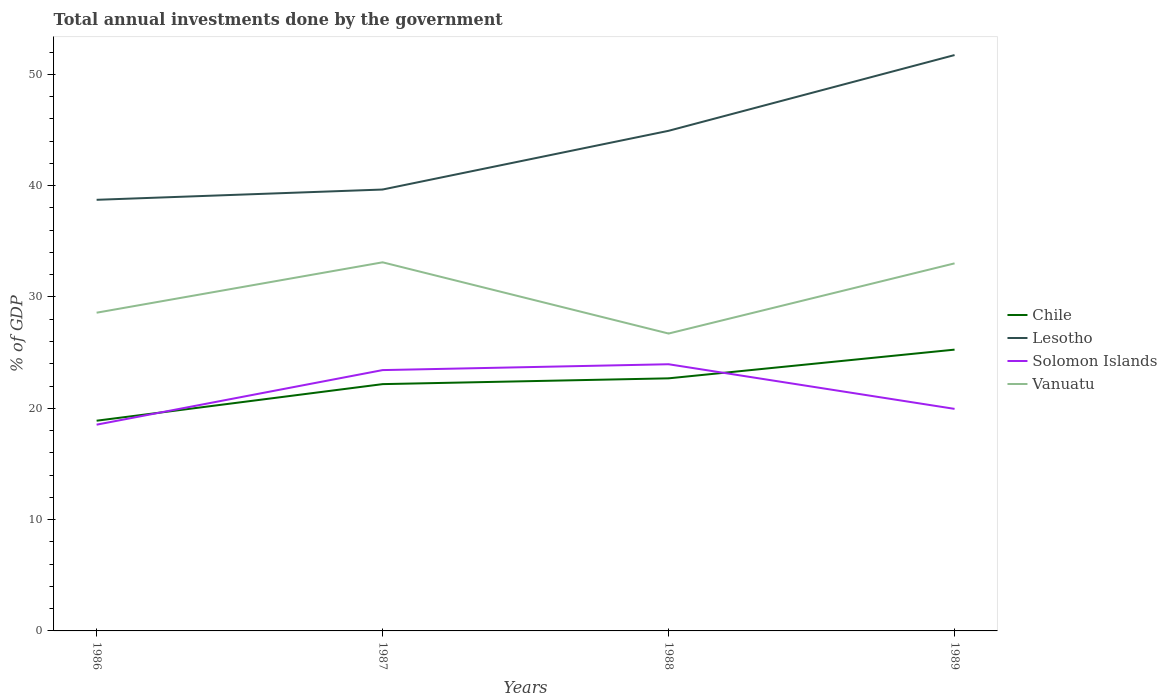Does the line corresponding to Lesotho intersect with the line corresponding to Solomon Islands?
Your response must be concise. No. Across all years, what is the maximum total annual investments done by the government in Chile?
Provide a succinct answer. 18.88. What is the total total annual investments done by the government in Vanuatu in the graph?
Your answer should be very brief. 6.4. What is the difference between the highest and the second highest total annual investments done by the government in Lesotho?
Your answer should be compact. 13. Is the total annual investments done by the government in Solomon Islands strictly greater than the total annual investments done by the government in Chile over the years?
Offer a terse response. No. How many years are there in the graph?
Your answer should be compact. 4. Does the graph contain any zero values?
Make the answer very short. No. How many legend labels are there?
Your answer should be very brief. 4. How are the legend labels stacked?
Your answer should be very brief. Vertical. What is the title of the graph?
Your answer should be compact. Total annual investments done by the government. What is the label or title of the Y-axis?
Offer a very short reply. % of GDP. What is the % of GDP of Chile in 1986?
Provide a succinct answer. 18.88. What is the % of GDP in Lesotho in 1986?
Your answer should be compact. 38.73. What is the % of GDP in Solomon Islands in 1986?
Your answer should be compact. 18.53. What is the % of GDP in Vanuatu in 1986?
Offer a very short reply. 28.59. What is the % of GDP of Chile in 1987?
Your answer should be compact. 22.17. What is the % of GDP of Lesotho in 1987?
Offer a very short reply. 39.65. What is the % of GDP in Solomon Islands in 1987?
Provide a short and direct response. 23.43. What is the % of GDP in Vanuatu in 1987?
Your response must be concise. 33.11. What is the % of GDP of Chile in 1988?
Provide a succinct answer. 22.69. What is the % of GDP in Lesotho in 1988?
Make the answer very short. 44.93. What is the % of GDP of Solomon Islands in 1988?
Your answer should be very brief. 23.96. What is the % of GDP in Vanuatu in 1988?
Make the answer very short. 26.71. What is the % of GDP of Chile in 1989?
Offer a very short reply. 25.27. What is the % of GDP of Lesotho in 1989?
Provide a short and direct response. 51.73. What is the % of GDP in Solomon Islands in 1989?
Ensure brevity in your answer.  19.95. What is the % of GDP of Vanuatu in 1989?
Offer a very short reply. 33.02. Across all years, what is the maximum % of GDP in Chile?
Keep it short and to the point. 25.27. Across all years, what is the maximum % of GDP of Lesotho?
Provide a succinct answer. 51.73. Across all years, what is the maximum % of GDP of Solomon Islands?
Ensure brevity in your answer.  23.96. Across all years, what is the maximum % of GDP of Vanuatu?
Ensure brevity in your answer.  33.11. Across all years, what is the minimum % of GDP of Chile?
Provide a succinct answer. 18.88. Across all years, what is the minimum % of GDP of Lesotho?
Make the answer very short. 38.73. Across all years, what is the minimum % of GDP in Solomon Islands?
Make the answer very short. 18.53. Across all years, what is the minimum % of GDP of Vanuatu?
Offer a terse response. 26.71. What is the total % of GDP of Chile in the graph?
Offer a terse response. 89.01. What is the total % of GDP in Lesotho in the graph?
Your response must be concise. 175.04. What is the total % of GDP of Solomon Islands in the graph?
Give a very brief answer. 85.86. What is the total % of GDP of Vanuatu in the graph?
Provide a succinct answer. 121.43. What is the difference between the % of GDP of Chile in 1986 and that in 1987?
Make the answer very short. -3.29. What is the difference between the % of GDP in Lesotho in 1986 and that in 1987?
Your response must be concise. -0.92. What is the difference between the % of GDP in Solomon Islands in 1986 and that in 1987?
Give a very brief answer. -4.9. What is the difference between the % of GDP of Vanuatu in 1986 and that in 1987?
Offer a terse response. -4.53. What is the difference between the % of GDP in Chile in 1986 and that in 1988?
Provide a succinct answer. -3.81. What is the difference between the % of GDP of Lesotho in 1986 and that in 1988?
Offer a very short reply. -6.2. What is the difference between the % of GDP of Solomon Islands in 1986 and that in 1988?
Your answer should be compact. -5.43. What is the difference between the % of GDP in Vanuatu in 1986 and that in 1988?
Your answer should be compact. 1.87. What is the difference between the % of GDP of Chile in 1986 and that in 1989?
Keep it short and to the point. -6.38. What is the difference between the % of GDP in Lesotho in 1986 and that in 1989?
Give a very brief answer. -13. What is the difference between the % of GDP in Solomon Islands in 1986 and that in 1989?
Provide a succinct answer. -1.42. What is the difference between the % of GDP in Vanuatu in 1986 and that in 1989?
Keep it short and to the point. -4.43. What is the difference between the % of GDP in Chile in 1987 and that in 1988?
Keep it short and to the point. -0.52. What is the difference between the % of GDP of Lesotho in 1987 and that in 1988?
Make the answer very short. -5.28. What is the difference between the % of GDP of Solomon Islands in 1987 and that in 1988?
Keep it short and to the point. -0.53. What is the difference between the % of GDP in Vanuatu in 1987 and that in 1988?
Your response must be concise. 6.4. What is the difference between the % of GDP of Chile in 1987 and that in 1989?
Your answer should be compact. -3.1. What is the difference between the % of GDP in Lesotho in 1987 and that in 1989?
Your response must be concise. -12.08. What is the difference between the % of GDP in Solomon Islands in 1987 and that in 1989?
Your answer should be compact. 3.48. What is the difference between the % of GDP of Vanuatu in 1987 and that in 1989?
Your answer should be very brief. 0.09. What is the difference between the % of GDP in Chile in 1988 and that in 1989?
Make the answer very short. -2.58. What is the difference between the % of GDP in Lesotho in 1988 and that in 1989?
Offer a very short reply. -6.8. What is the difference between the % of GDP of Solomon Islands in 1988 and that in 1989?
Your answer should be very brief. 4.01. What is the difference between the % of GDP in Vanuatu in 1988 and that in 1989?
Your answer should be compact. -6.3. What is the difference between the % of GDP in Chile in 1986 and the % of GDP in Lesotho in 1987?
Make the answer very short. -20.77. What is the difference between the % of GDP in Chile in 1986 and the % of GDP in Solomon Islands in 1987?
Your answer should be very brief. -4.55. What is the difference between the % of GDP of Chile in 1986 and the % of GDP of Vanuatu in 1987?
Make the answer very short. -14.23. What is the difference between the % of GDP in Lesotho in 1986 and the % of GDP in Solomon Islands in 1987?
Provide a short and direct response. 15.3. What is the difference between the % of GDP of Lesotho in 1986 and the % of GDP of Vanuatu in 1987?
Provide a succinct answer. 5.62. What is the difference between the % of GDP of Solomon Islands in 1986 and the % of GDP of Vanuatu in 1987?
Your answer should be very brief. -14.58. What is the difference between the % of GDP in Chile in 1986 and the % of GDP in Lesotho in 1988?
Offer a terse response. -26.04. What is the difference between the % of GDP in Chile in 1986 and the % of GDP in Solomon Islands in 1988?
Give a very brief answer. -5.07. What is the difference between the % of GDP in Chile in 1986 and the % of GDP in Vanuatu in 1988?
Ensure brevity in your answer.  -7.83. What is the difference between the % of GDP in Lesotho in 1986 and the % of GDP in Solomon Islands in 1988?
Provide a succinct answer. 14.77. What is the difference between the % of GDP of Lesotho in 1986 and the % of GDP of Vanuatu in 1988?
Keep it short and to the point. 12.01. What is the difference between the % of GDP of Solomon Islands in 1986 and the % of GDP of Vanuatu in 1988?
Your response must be concise. -8.19. What is the difference between the % of GDP of Chile in 1986 and the % of GDP of Lesotho in 1989?
Offer a terse response. -32.85. What is the difference between the % of GDP in Chile in 1986 and the % of GDP in Solomon Islands in 1989?
Keep it short and to the point. -1.06. What is the difference between the % of GDP in Chile in 1986 and the % of GDP in Vanuatu in 1989?
Provide a succinct answer. -14.13. What is the difference between the % of GDP in Lesotho in 1986 and the % of GDP in Solomon Islands in 1989?
Make the answer very short. 18.78. What is the difference between the % of GDP in Lesotho in 1986 and the % of GDP in Vanuatu in 1989?
Keep it short and to the point. 5.71. What is the difference between the % of GDP in Solomon Islands in 1986 and the % of GDP in Vanuatu in 1989?
Your answer should be compact. -14.49. What is the difference between the % of GDP of Chile in 1987 and the % of GDP of Lesotho in 1988?
Make the answer very short. -22.76. What is the difference between the % of GDP in Chile in 1987 and the % of GDP in Solomon Islands in 1988?
Give a very brief answer. -1.79. What is the difference between the % of GDP in Chile in 1987 and the % of GDP in Vanuatu in 1988?
Make the answer very short. -4.54. What is the difference between the % of GDP of Lesotho in 1987 and the % of GDP of Solomon Islands in 1988?
Provide a short and direct response. 15.7. What is the difference between the % of GDP of Lesotho in 1987 and the % of GDP of Vanuatu in 1988?
Provide a succinct answer. 12.94. What is the difference between the % of GDP of Solomon Islands in 1987 and the % of GDP of Vanuatu in 1988?
Provide a succinct answer. -3.28. What is the difference between the % of GDP in Chile in 1987 and the % of GDP in Lesotho in 1989?
Make the answer very short. -29.56. What is the difference between the % of GDP of Chile in 1987 and the % of GDP of Solomon Islands in 1989?
Ensure brevity in your answer.  2.22. What is the difference between the % of GDP of Chile in 1987 and the % of GDP of Vanuatu in 1989?
Your answer should be very brief. -10.85. What is the difference between the % of GDP in Lesotho in 1987 and the % of GDP in Solomon Islands in 1989?
Offer a very short reply. 19.7. What is the difference between the % of GDP of Lesotho in 1987 and the % of GDP of Vanuatu in 1989?
Offer a terse response. 6.63. What is the difference between the % of GDP of Solomon Islands in 1987 and the % of GDP of Vanuatu in 1989?
Your answer should be very brief. -9.59. What is the difference between the % of GDP in Chile in 1988 and the % of GDP in Lesotho in 1989?
Your answer should be compact. -29.04. What is the difference between the % of GDP of Chile in 1988 and the % of GDP of Solomon Islands in 1989?
Make the answer very short. 2.74. What is the difference between the % of GDP of Chile in 1988 and the % of GDP of Vanuatu in 1989?
Your answer should be compact. -10.33. What is the difference between the % of GDP of Lesotho in 1988 and the % of GDP of Solomon Islands in 1989?
Make the answer very short. 24.98. What is the difference between the % of GDP of Lesotho in 1988 and the % of GDP of Vanuatu in 1989?
Offer a terse response. 11.91. What is the difference between the % of GDP of Solomon Islands in 1988 and the % of GDP of Vanuatu in 1989?
Offer a terse response. -9.06. What is the average % of GDP of Chile per year?
Make the answer very short. 22.25. What is the average % of GDP in Lesotho per year?
Make the answer very short. 43.76. What is the average % of GDP in Solomon Islands per year?
Give a very brief answer. 21.47. What is the average % of GDP in Vanuatu per year?
Offer a terse response. 30.36. In the year 1986, what is the difference between the % of GDP of Chile and % of GDP of Lesotho?
Make the answer very short. -19.84. In the year 1986, what is the difference between the % of GDP in Chile and % of GDP in Solomon Islands?
Give a very brief answer. 0.36. In the year 1986, what is the difference between the % of GDP in Chile and % of GDP in Vanuatu?
Your answer should be very brief. -9.7. In the year 1986, what is the difference between the % of GDP of Lesotho and % of GDP of Solomon Islands?
Provide a succinct answer. 20.2. In the year 1986, what is the difference between the % of GDP of Lesotho and % of GDP of Vanuatu?
Keep it short and to the point. 10.14. In the year 1986, what is the difference between the % of GDP of Solomon Islands and % of GDP of Vanuatu?
Provide a succinct answer. -10.06. In the year 1987, what is the difference between the % of GDP of Chile and % of GDP of Lesotho?
Provide a succinct answer. -17.48. In the year 1987, what is the difference between the % of GDP of Chile and % of GDP of Solomon Islands?
Offer a terse response. -1.26. In the year 1987, what is the difference between the % of GDP of Chile and % of GDP of Vanuatu?
Keep it short and to the point. -10.94. In the year 1987, what is the difference between the % of GDP in Lesotho and % of GDP in Solomon Islands?
Your response must be concise. 16.22. In the year 1987, what is the difference between the % of GDP of Lesotho and % of GDP of Vanuatu?
Keep it short and to the point. 6.54. In the year 1987, what is the difference between the % of GDP of Solomon Islands and % of GDP of Vanuatu?
Your response must be concise. -9.68. In the year 1988, what is the difference between the % of GDP in Chile and % of GDP in Lesotho?
Give a very brief answer. -22.24. In the year 1988, what is the difference between the % of GDP in Chile and % of GDP in Solomon Islands?
Provide a short and direct response. -1.27. In the year 1988, what is the difference between the % of GDP of Chile and % of GDP of Vanuatu?
Offer a very short reply. -4.02. In the year 1988, what is the difference between the % of GDP in Lesotho and % of GDP in Solomon Islands?
Offer a very short reply. 20.97. In the year 1988, what is the difference between the % of GDP of Lesotho and % of GDP of Vanuatu?
Your response must be concise. 18.21. In the year 1988, what is the difference between the % of GDP in Solomon Islands and % of GDP in Vanuatu?
Provide a short and direct response. -2.76. In the year 1989, what is the difference between the % of GDP of Chile and % of GDP of Lesotho?
Give a very brief answer. -26.46. In the year 1989, what is the difference between the % of GDP in Chile and % of GDP in Solomon Islands?
Make the answer very short. 5.32. In the year 1989, what is the difference between the % of GDP in Chile and % of GDP in Vanuatu?
Give a very brief answer. -7.75. In the year 1989, what is the difference between the % of GDP in Lesotho and % of GDP in Solomon Islands?
Offer a very short reply. 31.78. In the year 1989, what is the difference between the % of GDP of Lesotho and % of GDP of Vanuatu?
Provide a short and direct response. 18.71. In the year 1989, what is the difference between the % of GDP of Solomon Islands and % of GDP of Vanuatu?
Offer a very short reply. -13.07. What is the ratio of the % of GDP of Chile in 1986 to that in 1987?
Make the answer very short. 0.85. What is the ratio of the % of GDP in Lesotho in 1986 to that in 1987?
Provide a succinct answer. 0.98. What is the ratio of the % of GDP of Solomon Islands in 1986 to that in 1987?
Your response must be concise. 0.79. What is the ratio of the % of GDP in Vanuatu in 1986 to that in 1987?
Your answer should be very brief. 0.86. What is the ratio of the % of GDP in Chile in 1986 to that in 1988?
Your response must be concise. 0.83. What is the ratio of the % of GDP of Lesotho in 1986 to that in 1988?
Keep it short and to the point. 0.86. What is the ratio of the % of GDP of Solomon Islands in 1986 to that in 1988?
Your response must be concise. 0.77. What is the ratio of the % of GDP in Vanuatu in 1986 to that in 1988?
Make the answer very short. 1.07. What is the ratio of the % of GDP of Chile in 1986 to that in 1989?
Make the answer very short. 0.75. What is the ratio of the % of GDP of Lesotho in 1986 to that in 1989?
Keep it short and to the point. 0.75. What is the ratio of the % of GDP of Solomon Islands in 1986 to that in 1989?
Provide a short and direct response. 0.93. What is the ratio of the % of GDP in Vanuatu in 1986 to that in 1989?
Offer a very short reply. 0.87. What is the ratio of the % of GDP in Chile in 1987 to that in 1988?
Your response must be concise. 0.98. What is the ratio of the % of GDP of Lesotho in 1987 to that in 1988?
Give a very brief answer. 0.88. What is the ratio of the % of GDP in Solomon Islands in 1987 to that in 1988?
Offer a terse response. 0.98. What is the ratio of the % of GDP of Vanuatu in 1987 to that in 1988?
Offer a terse response. 1.24. What is the ratio of the % of GDP of Chile in 1987 to that in 1989?
Your answer should be compact. 0.88. What is the ratio of the % of GDP in Lesotho in 1987 to that in 1989?
Make the answer very short. 0.77. What is the ratio of the % of GDP of Solomon Islands in 1987 to that in 1989?
Make the answer very short. 1.17. What is the ratio of the % of GDP in Chile in 1988 to that in 1989?
Offer a terse response. 0.9. What is the ratio of the % of GDP in Lesotho in 1988 to that in 1989?
Ensure brevity in your answer.  0.87. What is the ratio of the % of GDP of Solomon Islands in 1988 to that in 1989?
Your answer should be very brief. 1.2. What is the ratio of the % of GDP in Vanuatu in 1988 to that in 1989?
Make the answer very short. 0.81. What is the difference between the highest and the second highest % of GDP of Chile?
Your answer should be compact. 2.58. What is the difference between the highest and the second highest % of GDP of Lesotho?
Offer a terse response. 6.8. What is the difference between the highest and the second highest % of GDP of Solomon Islands?
Your answer should be compact. 0.53. What is the difference between the highest and the second highest % of GDP in Vanuatu?
Offer a terse response. 0.09. What is the difference between the highest and the lowest % of GDP of Chile?
Provide a short and direct response. 6.38. What is the difference between the highest and the lowest % of GDP of Lesotho?
Offer a very short reply. 13. What is the difference between the highest and the lowest % of GDP of Solomon Islands?
Provide a succinct answer. 5.43. What is the difference between the highest and the lowest % of GDP of Vanuatu?
Your answer should be compact. 6.4. 